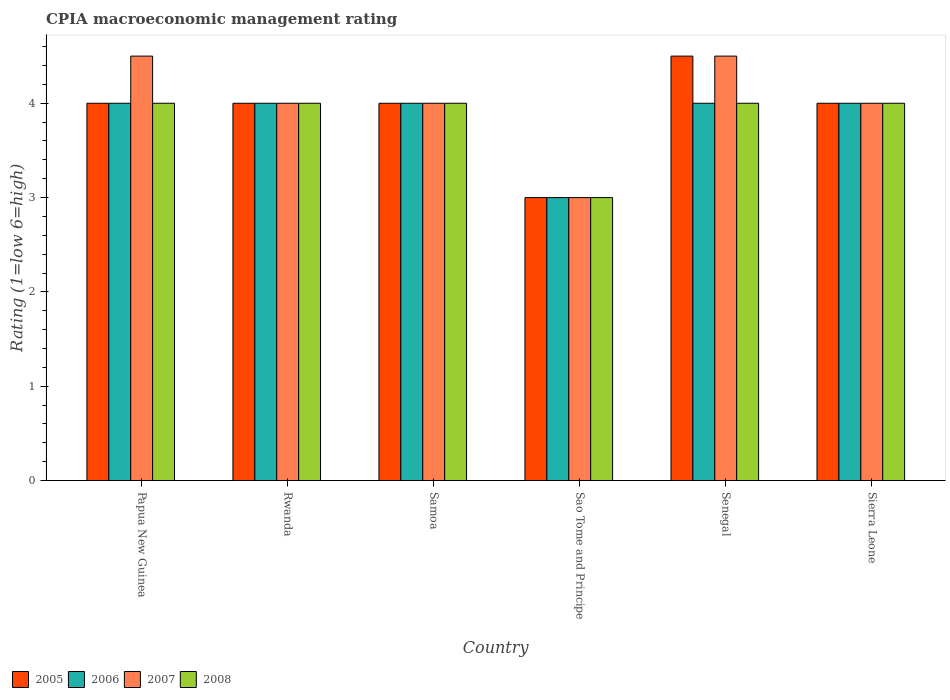How many different coloured bars are there?
Provide a short and direct response. 4. How many bars are there on the 5th tick from the left?
Offer a terse response. 4. What is the label of the 4th group of bars from the left?
Ensure brevity in your answer.  Sao Tome and Principe. In how many cases, is the number of bars for a given country not equal to the number of legend labels?
Your answer should be compact. 0. Across all countries, what is the minimum CPIA rating in 2007?
Offer a terse response. 3. In which country was the CPIA rating in 2007 maximum?
Ensure brevity in your answer.  Papua New Guinea. In which country was the CPIA rating in 2005 minimum?
Your response must be concise. Sao Tome and Principe. What is the total CPIA rating in 2006 in the graph?
Offer a very short reply. 23. What is the difference between the CPIA rating in 2007 in Samoa and that in Senegal?
Provide a succinct answer. -0.5. In how many countries, is the CPIA rating in 2005 greater than 2.6?
Make the answer very short. 6. What is the ratio of the CPIA rating in 2006 in Papua New Guinea to that in Senegal?
Make the answer very short. 1. What is the difference between the highest and the second highest CPIA rating in 2005?
Give a very brief answer. 0.5. Is the sum of the CPIA rating in 2007 in Samoa and Sao Tome and Principe greater than the maximum CPIA rating in 2008 across all countries?
Your answer should be compact. Yes. What does the 2nd bar from the left in Sierra Leone represents?
Make the answer very short. 2006. Is it the case that in every country, the sum of the CPIA rating in 2006 and CPIA rating in 2005 is greater than the CPIA rating in 2007?
Give a very brief answer. Yes. Are all the bars in the graph horizontal?
Your answer should be compact. No. How many countries are there in the graph?
Offer a terse response. 6. Does the graph contain any zero values?
Your response must be concise. No. Does the graph contain grids?
Your answer should be very brief. No. How are the legend labels stacked?
Keep it short and to the point. Horizontal. What is the title of the graph?
Give a very brief answer. CPIA macroeconomic management rating. Does "1973" appear as one of the legend labels in the graph?
Your answer should be compact. No. What is the label or title of the Y-axis?
Offer a very short reply. Rating (1=low 6=high). What is the Rating (1=low 6=high) of 2005 in Papua New Guinea?
Make the answer very short. 4. What is the Rating (1=low 6=high) in 2007 in Papua New Guinea?
Offer a very short reply. 4.5. What is the Rating (1=low 6=high) of 2008 in Papua New Guinea?
Give a very brief answer. 4. What is the Rating (1=low 6=high) in 2007 in Rwanda?
Keep it short and to the point. 4. What is the Rating (1=low 6=high) of 2007 in Samoa?
Provide a short and direct response. 4. What is the Rating (1=low 6=high) of 2006 in Sao Tome and Principe?
Make the answer very short. 3. What is the Rating (1=low 6=high) in 2005 in Senegal?
Give a very brief answer. 4.5. What is the Rating (1=low 6=high) in 2006 in Senegal?
Provide a short and direct response. 4. What is the Rating (1=low 6=high) in 2008 in Senegal?
Provide a succinct answer. 4. What is the Rating (1=low 6=high) of 2006 in Sierra Leone?
Offer a very short reply. 4. What is the Rating (1=low 6=high) of 2007 in Sierra Leone?
Provide a short and direct response. 4. What is the Rating (1=low 6=high) in 2008 in Sierra Leone?
Your answer should be very brief. 4. Across all countries, what is the maximum Rating (1=low 6=high) in 2006?
Your response must be concise. 4. Across all countries, what is the maximum Rating (1=low 6=high) in 2007?
Offer a very short reply. 4.5. Across all countries, what is the minimum Rating (1=low 6=high) in 2006?
Your answer should be compact. 3. Across all countries, what is the minimum Rating (1=low 6=high) of 2007?
Provide a succinct answer. 3. Across all countries, what is the minimum Rating (1=low 6=high) in 2008?
Keep it short and to the point. 3. What is the total Rating (1=low 6=high) in 2005 in the graph?
Your answer should be very brief. 23.5. What is the total Rating (1=low 6=high) in 2006 in the graph?
Offer a terse response. 23. What is the total Rating (1=low 6=high) in 2007 in the graph?
Ensure brevity in your answer.  24. What is the difference between the Rating (1=low 6=high) of 2005 in Papua New Guinea and that in Rwanda?
Provide a short and direct response. 0. What is the difference between the Rating (1=low 6=high) of 2007 in Papua New Guinea and that in Rwanda?
Make the answer very short. 0.5. What is the difference between the Rating (1=low 6=high) in 2008 in Papua New Guinea and that in Rwanda?
Your response must be concise. 0. What is the difference between the Rating (1=low 6=high) in 2008 in Papua New Guinea and that in Samoa?
Make the answer very short. 0. What is the difference between the Rating (1=low 6=high) in 2007 in Papua New Guinea and that in Sao Tome and Principe?
Offer a terse response. 1.5. What is the difference between the Rating (1=low 6=high) of 2008 in Papua New Guinea and that in Sao Tome and Principe?
Offer a very short reply. 1. What is the difference between the Rating (1=low 6=high) of 2006 in Papua New Guinea and that in Senegal?
Provide a succinct answer. 0. What is the difference between the Rating (1=low 6=high) in 2007 in Papua New Guinea and that in Senegal?
Keep it short and to the point. 0. What is the difference between the Rating (1=low 6=high) in 2008 in Papua New Guinea and that in Senegal?
Give a very brief answer. 0. What is the difference between the Rating (1=low 6=high) in 2005 in Papua New Guinea and that in Sierra Leone?
Provide a succinct answer. 0. What is the difference between the Rating (1=low 6=high) in 2006 in Papua New Guinea and that in Sierra Leone?
Provide a succinct answer. 0. What is the difference between the Rating (1=low 6=high) in 2007 in Papua New Guinea and that in Sierra Leone?
Your answer should be compact. 0.5. What is the difference between the Rating (1=low 6=high) of 2008 in Papua New Guinea and that in Sierra Leone?
Ensure brevity in your answer.  0. What is the difference between the Rating (1=low 6=high) of 2007 in Rwanda and that in Samoa?
Offer a terse response. 0. What is the difference between the Rating (1=low 6=high) in 2006 in Rwanda and that in Sao Tome and Principe?
Offer a very short reply. 1. What is the difference between the Rating (1=low 6=high) of 2007 in Rwanda and that in Sao Tome and Principe?
Give a very brief answer. 1. What is the difference between the Rating (1=low 6=high) of 2008 in Rwanda and that in Sao Tome and Principe?
Keep it short and to the point. 1. What is the difference between the Rating (1=low 6=high) of 2005 in Rwanda and that in Senegal?
Ensure brevity in your answer.  -0.5. What is the difference between the Rating (1=low 6=high) of 2007 in Rwanda and that in Senegal?
Provide a succinct answer. -0.5. What is the difference between the Rating (1=low 6=high) of 2008 in Rwanda and that in Senegal?
Make the answer very short. 0. What is the difference between the Rating (1=low 6=high) of 2005 in Rwanda and that in Sierra Leone?
Make the answer very short. 0. What is the difference between the Rating (1=low 6=high) of 2005 in Samoa and that in Sao Tome and Principe?
Provide a succinct answer. 1. What is the difference between the Rating (1=low 6=high) of 2006 in Samoa and that in Sao Tome and Principe?
Make the answer very short. 1. What is the difference between the Rating (1=low 6=high) in 2007 in Samoa and that in Sao Tome and Principe?
Make the answer very short. 1. What is the difference between the Rating (1=low 6=high) in 2008 in Samoa and that in Sao Tome and Principe?
Offer a terse response. 1. What is the difference between the Rating (1=low 6=high) in 2005 in Samoa and that in Sierra Leone?
Your answer should be very brief. 0. What is the difference between the Rating (1=low 6=high) of 2006 in Samoa and that in Sierra Leone?
Ensure brevity in your answer.  0. What is the difference between the Rating (1=low 6=high) of 2007 in Samoa and that in Sierra Leone?
Your response must be concise. 0. What is the difference between the Rating (1=low 6=high) in 2008 in Samoa and that in Sierra Leone?
Make the answer very short. 0. What is the difference between the Rating (1=low 6=high) of 2007 in Sao Tome and Principe and that in Senegal?
Keep it short and to the point. -1.5. What is the difference between the Rating (1=low 6=high) of 2007 in Senegal and that in Sierra Leone?
Your response must be concise. 0.5. What is the difference between the Rating (1=low 6=high) of 2005 in Papua New Guinea and the Rating (1=low 6=high) of 2007 in Rwanda?
Your answer should be very brief. 0. What is the difference between the Rating (1=low 6=high) of 2005 in Papua New Guinea and the Rating (1=low 6=high) of 2008 in Rwanda?
Provide a short and direct response. 0. What is the difference between the Rating (1=low 6=high) of 2006 in Papua New Guinea and the Rating (1=low 6=high) of 2007 in Rwanda?
Make the answer very short. 0. What is the difference between the Rating (1=low 6=high) in 2006 in Papua New Guinea and the Rating (1=low 6=high) in 2008 in Rwanda?
Keep it short and to the point. 0. What is the difference between the Rating (1=low 6=high) of 2005 in Papua New Guinea and the Rating (1=low 6=high) of 2006 in Samoa?
Ensure brevity in your answer.  0. What is the difference between the Rating (1=low 6=high) in 2005 in Papua New Guinea and the Rating (1=low 6=high) in 2007 in Samoa?
Provide a short and direct response. 0. What is the difference between the Rating (1=low 6=high) of 2006 in Papua New Guinea and the Rating (1=low 6=high) of 2007 in Samoa?
Ensure brevity in your answer.  0. What is the difference between the Rating (1=low 6=high) in 2005 in Papua New Guinea and the Rating (1=low 6=high) in 2007 in Sao Tome and Principe?
Provide a succinct answer. 1. What is the difference between the Rating (1=low 6=high) of 2006 in Papua New Guinea and the Rating (1=low 6=high) of 2007 in Sao Tome and Principe?
Give a very brief answer. 1. What is the difference between the Rating (1=low 6=high) of 2006 in Papua New Guinea and the Rating (1=low 6=high) of 2008 in Sao Tome and Principe?
Your answer should be very brief. 1. What is the difference between the Rating (1=low 6=high) of 2005 in Papua New Guinea and the Rating (1=low 6=high) of 2006 in Senegal?
Offer a terse response. 0. What is the difference between the Rating (1=low 6=high) in 2005 in Papua New Guinea and the Rating (1=low 6=high) in 2007 in Senegal?
Keep it short and to the point. -0.5. What is the difference between the Rating (1=low 6=high) of 2005 in Papua New Guinea and the Rating (1=low 6=high) of 2008 in Senegal?
Offer a very short reply. 0. What is the difference between the Rating (1=low 6=high) in 2006 in Papua New Guinea and the Rating (1=low 6=high) in 2008 in Senegal?
Offer a very short reply. 0. What is the difference between the Rating (1=low 6=high) of 2006 in Papua New Guinea and the Rating (1=low 6=high) of 2007 in Sierra Leone?
Offer a very short reply. 0. What is the difference between the Rating (1=low 6=high) in 2007 in Papua New Guinea and the Rating (1=low 6=high) in 2008 in Sierra Leone?
Make the answer very short. 0.5. What is the difference between the Rating (1=low 6=high) of 2005 in Rwanda and the Rating (1=low 6=high) of 2006 in Sao Tome and Principe?
Your response must be concise. 1. What is the difference between the Rating (1=low 6=high) of 2005 in Rwanda and the Rating (1=low 6=high) of 2007 in Sao Tome and Principe?
Provide a succinct answer. 1. What is the difference between the Rating (1=low 6=high) of 2006 in Rwanda and the Rating (1=low 6=high) of 2007 in Sao Tome and Principe?
Your answer should be compact. 1. What is the difference between the Rating (1=low 6=high) in 2006 in Rwanda and the Rating (1=low 6=high) in 2008 in Sao Tome and Principe?
Ensure brevity in your answer.  1. What is the difference between the Rating (1=low 6=high) in 2007 in Rwanda and the Rating (1=low 6=high) in 2008 in Sao Tome and Principe?
Your answer should be compact. 1. What is the difference between the Rating (1=low 6=high) in 2005 in Rwanda and the Rating (1=low 6=high) in 2007 in Senegal?
Offer a very short reply. -0.5. What is the difference between the Rating (1=low 6=high) of 2005 in Rwanda and the Rating (1=low 6=high) of 2008 in Senegal?
Your answer should be very brief. 0. What is the difference between the Rating (1=low 6=high) in 2006 in Rwanda and the Rating (1=low 6=high) in 2007 in Senegal?
Provide a short and direct response. -0.5. What is the difference between the Rating (1=low 6=high) of 2006 in Rwanda and the Rating (1=low 6=high) of 2008 in Senegal?
Your answer should be compact. 0. What is the difference between the Rating (1=low 6=high) of 2007 in Rwanda and the Rating (1=low 6=high) of 2008 in Senegal?
Your answer should be compact. 0. What is the difference between the Rating (1=low 6=high) of 2005 in Rwanda and the Rating (1=low 6=high) of 2007 in Sierra Leone?
Your answer should be very brief. 0. What is the difference between the Rating (1=low 6=high) of 2006 in Rwanda and the Rating (1=low 6=high) of 2007 in Sierra Leone?
Your answer should be compact. 0. What is the difference between the Rating (1=low 6=high) of 2006 in Rwanda and the Rating (1=low 6=high) of 2008 in Sierra Leone?
Keep it short and to the point. 0. What is the difference between the Rating (1=low 6=high) of 2005 in Samoa and the Rating (1=low 6=high) of 2006 in Sao Tome and Principe?
Ensure brevity in your answer.  1. What is the difference between the Rating (1=low 6=high) in 2005 in Samoa and the Rating (1=low 6=high) in 2008 in Sao Tome and Principe?
Your answer should be very brief. 1. What is the difference between the Rating (1=low 6=high) of 2006 in Samoa and the Rating (1=low 6=high) of 2008 in Sao Tome and Principe?
Provide a succinct answer. 1. What is the difference between the Rating (1=low 6=high) of 2007 in Samoa and the Rating (1=low 6=high) of 2008 in Sao Tome and Principe?
Offer a very short reply. 1. What is the difference between the Rating (1=low 6=high) of 2005 in Samoa and the Rating (1=low 6=high) of 2006 in Senegal?
Your answer should be compact. 0. What is the difference between the Rating (1=low 6=high) in 2005 in Samoa and the Rating (1=low 6=high) in 2008 in Senegal?
Make the answer very short. 0. What is the difference between the Rating (1=low 6=high) of 2006 in Samoa and the Rating (1=low 6=high) of 2008 in Senegal?
Provide a short and direct response. 0. What is the difference between the Rating (1=low 6=high) of 2007 in Samoa and the Rating (1=low 6=high) of 2008 in Senegal?
Your answer should be very brief. 0. What is the difference between the Rating (1=low 6=high) of 2005 in Samoa and the Rating (1=low 6=high) of 2007 in Sierra Leone?
Keep it short and to the point. 0. What is the difference between the Rating (1=low 6=high) in 2006 in Samoa and the Rating (1=low 6=high) in 2007 in Sierra Leone?
Your response must be concise. 0. What is the difference between the Rating (1=low 6=high) of 2006 in Samoa and the Rating (1=low 6=high) of 2008 in Sierra Leone?
Your response must be concise. 0. What is the difference between the Rating (1=low 6=high) of 2007 in Samoa and the Rating (1=low 6=high) of 2008 in Sierra Leone?
Provide a succinct answer. 0. What is the difference between the Rating (1=low 6=high) in 2005 in Sao Tome and Principe and the Rating (1=low 6=high) in 2008 in Senegal?
Ensure brevity in your answer.  -1. What is the difference between the Rating (1=low 6=high) of 2006 in Sao Tome and Principe and the Rating (1=low 6=high) of 2007 in Senegal?
Keep it short and to the point. -1.5. What is the difference between the Rating (1=low 6=high) in 2006 in Sao Tome and Principe and the Rating (1=low 6=high) in 2008 in Senegal?
Offer a terse response. -1. What is the difference between the Rating (1=low 6=high) in 2007 in Sao Tome and Principe and the Rating (1=low 6=high) in 2008 in Senegal?
Your answer should be compact. -1. What is the difference between the Rating (1=low 6=high) in 2006 in Sao Tome and Principe and the Rating (1=low 6=high) in 2007 in Sierra Leone?
Give a very brief answer. -1. What is the difference between the Rating (1=low 6=high) of 2006 in Sao Tome and Principe and the Rating (1=low 6=high) of 2008 in Sierra Leone?
Your answer should be very brief. -1. What is the difference between the Rating (1=low 6=high) of 2007 in Sao Tome and Principe and the Rating (1=low 6=high) of 2008 in Sierra Leone?
Offer a terse response. -1. What is the difference between the Rating (1=low 6=high) in 2005 in Senegal and the Rating (1=low 6=high) in 2006 in Sierra Leone?
Your answer should be compact. 0.5. What is the difference between the Rating (1=low 6=high) of 2006 in Senegal and the Rating (1=low 6=high) of 2007 in Sierra Leone?
Your response must be concise. 0. What is the difference between the Rating (1=low 6=high) in 2007 in Senegal and the Rating (1=low 6=high) in 2008 in Sierra Leone?
Offer a very short reply. 0.5. What is the average Rating (1=low 6=high) of 2005 per country?
Ensure brevity in your answer.  3.92. What is the average Rating (1=low 6=high) in 2006 per country?
Make the answer very short. 3.83. What is the average Rating (1=low 6=high) of 2007 per country?
Your answer should be compact. 4. What is the average Rating (1=low 6=high) in 2008 per country?
Provide a succinct answer. 3.83. What is the difference between the Rating (1=low 6=high) in 2005 and Rating (1=low 6=high) in 2006 in Papua New Guinea?
Provide a short and direct response. 0. What is the difference between the Rating (1=low 6=high) in 2006 and Rating (1=low 6=high) in 2007 in Papua New Guinea?
Make the answer very short. -0.5. What is the difference between the Rating (1=low 6=high) of 2006 and Rating (1=low 6=high) of 2008 in Papua New Guinea?
Offer a terse response. 0. What is the difference between the Rating (1=low 6=high) of 2005 and Rating (1=low 6=high) of 2007 in Rwanda?
Provide a short and direct response. 0. What is the difference between the Rating (1=low 6=high) of 2005 and Rating (1=low 6=high) of 2008 in Rwanda?
Offer a very short reply. 0. What is the difference between the Rating (1=low 6=high) in 2006 and Rating (1=low 6=high) in 2008 in Rwanda?
Your response must be concise. 0. What is the difference between the Rating (1=low 6=high) in 2005 and Rating (1=low 6=high) in 2007 in Samoa?
Provide a short and direct response. 0. What is the difference between the Rating (1=low 6=high) of 2006 and Rating (1=low 6=high) of 2007 in Samoa?
Your response must be concise. 0. What is the difference between the Rating (1=low 6=high) in 2007 and Rating (1=low 6=high) in 2008 in Samoa?
Offer a terse response. 0. What is the difference between the Rating (1=low 6=high) in 2005 and Rating (1=low 6=high) in 2008 in Sao Tome and Principe?
Ensure brevity in your answer.  0. What is the difference between the Rating (1=low 6=high) in 2006 and Rating (1=low 6=high) in 2007 in Sao Tome and Principe?
Your answer should be very brief. 0. What is the difference between the Rating (1=low 6=high) of 2006 and Rating (1=low 6=high) of 2008 in Sao Tome and Principe?
Give a very brief answer. 0. What is the difference between the Rating (1=low 6=high) of 2005 and Rating (1=low 6=high) of 2007 in Senegal?
Offer a terse response. 0. What is the difference between the Rating (1=low 6=high) in 2005 and Rating (1=low 6=high) in 2008 in Senegal?
Provide a succinct answer. 0.5. What is the difference between the Rating (1=low 6=high) of 2006 and Rating (1=low 6=high) of 2008 in Senegal?
Ensure brevity in your answer.  0. What is the difference between the Rating (1=low 6=high) in 2005 and Rating (1=low 6=high) in 2006 in Sierra Leone?
Ensure brevity in your answer.  0. What is the difference between the Rating (1=low 6=high) in 2005 and Rating (1=low 6=high) in 2008 in Sierra Leone?
Keep it short and to the point. 0. What is the difference between the Rating (1=low 6=high) in 2006 and Rating (1=low 6=high) in 2008 in Sierra Leone?
Provide a short and direct response. 0. What is the ratio of the Rating (1=low 6=high) in 2005 in Papua New Guinea to that in Rwanda?
Offer a terse response. 1. What is the ratio of the Rating (1=low 6=high) in 2007 in Papua New Guinea to that in Rwanda?
Your answer should be compact. 1.12. What is the ratio of the Rating (1=low 6=high) of 2008 in Papua New Guinea to that in Rwanda?
Provide a succinct answer. 1. What is the ratio of the Rating (1=low 6=high) in 2007 in Papua New Guinea to that in Samoa?
Give a very brief answer. 1.12. What is the ratio of the Rating (1=low 6=high) of 2006 in Papua New Guinea to that in Sao Tome and Principe?
Keep it short and to the point. 1.33. What is the ratio of the Rating (1=low 6=high) of 2007 in Papua New Guinea to that in Sao Tome and Principe?
Offer a very short reply. 1.5. What is the ratio of the Rating (1=low 6=high) of 2005 in Papua New Guinea to that in Senegal?
Ensure brevity in your answer.  0.89. What is the ratio of the Rating (1=low 6=high) in 2006 in Papua New Guinea to that in Senegal?
Ensure brevity in your answer.  1. What is the ratio of the Rating (1=low 6=high) in 2007 in Papua New Guinea to that in Senegal?
Offer a terse response. 1. What is the ratio of the Rating (1=low 6=high) of 2008 in Papua New Guinea to that in Senegal?
Provide a short and direct response. 1. What is the ratio of the Rating (1=low 6=high) of 2006 in Papua New Guinea to that in Sierra Leone?
Give a very brief answer. 1. What is the ratio of the Rating (1=low 6=high) in 2007 in Papua New Guinea to that in Sierra Leone?
Offer a terse response. 1.12. What is the ratio of the Rating (1=low 6=high) in 2008 in Papua New Guinea to that in Sierra Leone?
Keep it short and to the point. 1. What is the ratio of the Rating (1=low 6=high) in 2005 in Rwanda to that in Samoa?
Your response must be concise. 1. What is the ratio of the Rating (1=low 6=high) in 2008 in Rwanda to that in Samoa?
Ensure brevity in your answer.  1. What is the ratio of the Rating (1=low 6=high) in 2006 in Rwanda to that in Sao Tome and Principe?
Provide a short and direct response. 1.33. What is the ratio of the Rating (1=low 6=high) in 2008 in Rwanda to that in Sao Tome and Principe?
Offer a terse response. 1.33. What is the ratio of the Rating (1=low 6=high) in 2008 in Rwanda to that in Senegal?
Make the answer very short. 1. What is the ratio of the Rating (1=low 6=high) in 2005 in Rwanda to that in Sierra Leone?
Ensure brevity in your answer.  1. What is the ratio of the Rating (1=low 6=high) in 2005 in Samoa to that in Sao Tome and Principe?
Offer a terse response. 1.33. What is the ratio of the Rating (1=low 6=high) of 2006 in Samoa to that in Sao Tome and Principe?
Provide a short and direct response. 1.33. What is the ratio of the Rating (1=low 6=high) in 2008 in Samoa to that in Sao Tome and Principe?
Your response must be concise. 1.33. What is the ratio of the Rating (1=low 6=high) in 2005 in Samoa to that in Senegal?
Ensure brevity in your answer.  0.89. What is the ratio of the Rating (1=low 6=high) in 2008 in Samoa to that in Senegal?
Ensure brevity in your answer.  1. What is the ratio of the Rating (1=low 6=high) in 2007 in Samoa to that in Sierra Leone?
Provide a short and direct response. 1. What is the ratio of the Rating (1=low 6=high) in 2008 in Samoa to that in Sierra Leone?
Keep it short and to the point. 1. What is the ratio of the Rating (1=low 6=high) in 2005 in Sao Tome and Principe to that in Senegal?
Offer a terse response. 0.67. What is the ratio of the Rating (1=low 6=high) in 2006 in Sao Tome and Principe to that in Senegal?
Give a very brief answer. 0.75. What is the ratio of the Rating (1=low 6=high) of 2005 in Sao Tome and Principe to that in Sierra Leone?
Provide a short and direct response. 0.75. What is the ratio of the Rating (1=low 6=high) in 2006 in Sao Tome and Principe to that in Sierra Leone?
Give a very brief answer. 0.75. What is the ratio of the Rating (1=low 6=high) in 2007 in Sao Tome and Principe to that in Sierra Leone?
Provide a short and direct response. 0.75. What is the ratio of the Rating (1=low 6=high) in 2008 in Sao Tome and Principe to that in Sierra Leone?
Offer a very short reply. 0.75. What is the ratio of the Rating (1=low 6=high) in 2006 in Senegal to that in Sierra Leone?
Make the answer very short. 1. What is the ratio of the Rating (1=low 6=high) in 2007 in Senegal to that in Sierra Leone?
Offer a terse response. 1.12. What is the ratio of the Rating (1=low 6=high) of 2008 in Senegal to that in Sierra Leone?
Offer a terse response. 1. What is the difference between the highest and the second highest Rating (1=low 6=high) of 2007?
Make the answer very short. 0. What is the difference between the highest and the lowest Rating (1=low 6=high) in 2005?
Ensure brevity in your answer.  1.5. What is the difference between the highest and the lowest Rating (1=low 6=high) in 2007?
Make the answer very short. 1.5. What is the difference between the highest and the lowest Rating (1=low 6=high) in 2008?
Ensure brevity in your answer.  1. 